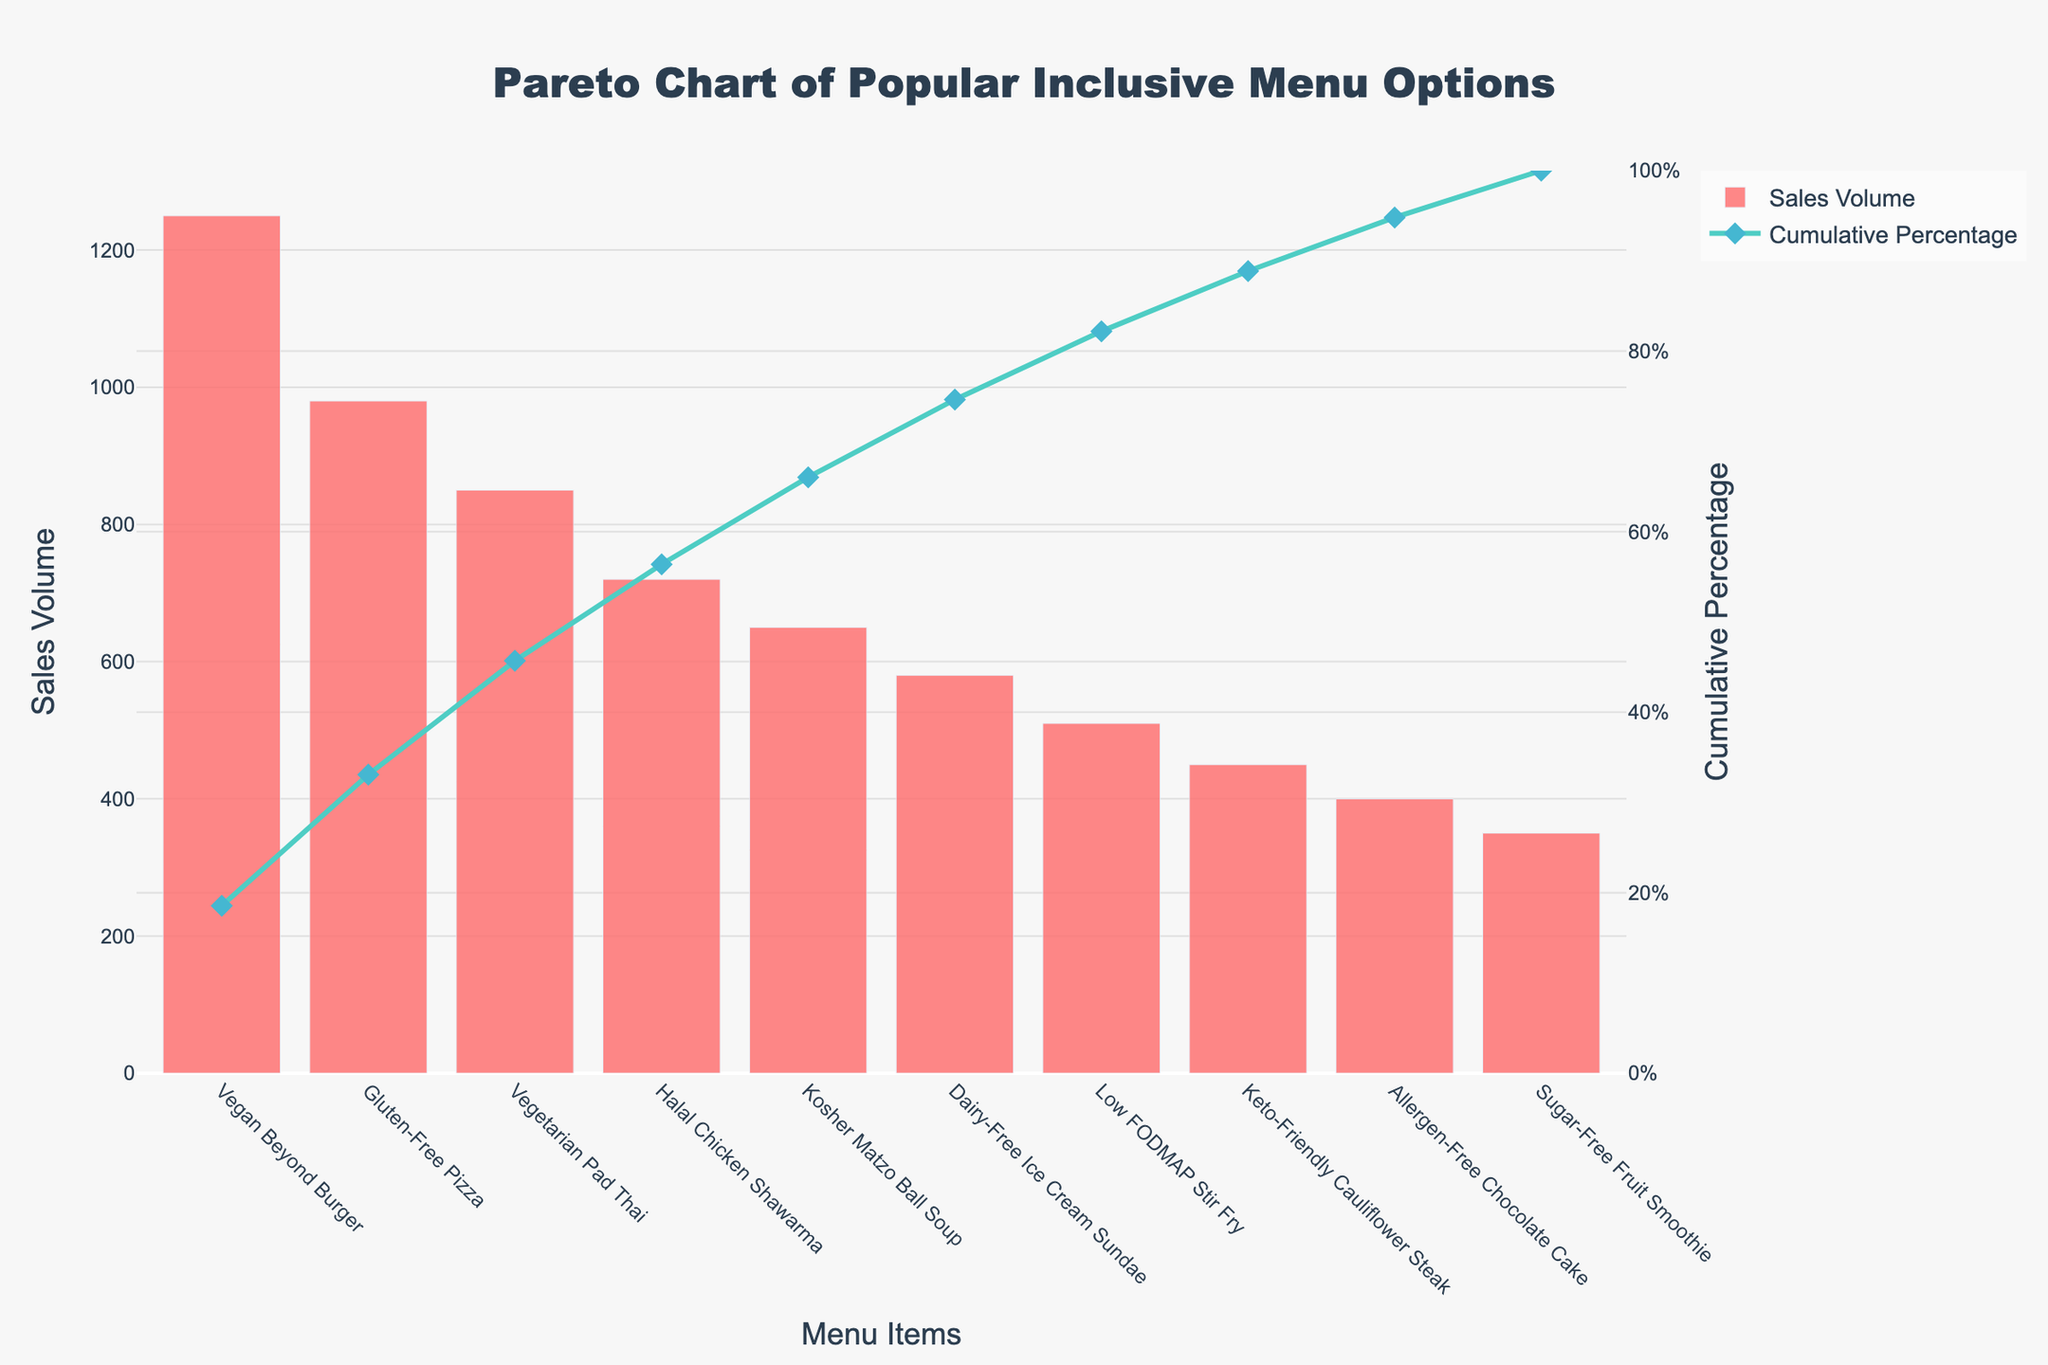What is the title of the chart? The title is displayed at the top of the chart and is "Pareto Chart of Popular Inclusive Menu Options".
Answer: Pareto Chart of Popular Inclusive Menu Options What are the top three menu items with the highest sales volume? By looking at the height of the bars, you can identify the top three menu items by their sales volume: "Vegan Beyond Burger", "Gluten-Free Pizza", and "Vegetarian Pad Thai".
Answer: Vegan Beyond Burger, Gluten-Free Pizza, Vegetarian Pad Thai Which menu item has the lowest sales volume? The shortest bar indicates the menu item with the lowest sales volume, which is "Sugar-Free Fruit Smoothie".
Answer: Sugar-Free Fruit Smoothie What is the color of the bars representing sales volume? The bars representing sales volume are in a specific color that is shown prominently in the chart.
Answer: Red What is the cumulative percentage for "Vegetarian Pad Thai"? The cumulative percentage line shows the cumulative percentage up to "Vegetarian Pad Thai", which is approximately 65%.
Answer: 65% How many menu items are represented in the chart? Counting the number of bars or x-axis labels will give the total number of menu items represented.
Answer: 10 (Compositional) What is the total sales volume for "Vegan Beyond Burger" and "Gluten-Free Pizza"? Summing the sales volumes of "Vegan Beyond Burger" (1250) and "Gluten-Free Pizza" (980) gives a total of 2230.
Answer: 2230 (Comparison) Which has a higher sales volume: "Halal Chicken Shawarma" or "Kosher Matzo Ball Soup"? By comparing the heights of their bars, "Halal Chicken Shawarma" has higher sales volume (720) than "Kosher Matzo Ball Soup" (650).
Answer: Halal Chicken Shawarma (Comparison) How does the cumulative percentage change from "Halal Chicken Shawarma" to "Kosher Matzo Ball Soup"? The cumulative percentage line shows an increase from 55% for "Halal Chicken Shawarma" to approximately 65% for "Kosher Matzo Ball Soup".
Answer: 10% (Chart-Type Specific) At which menu item does the cumulative percentage reach 100%? The cumulative percentage line reaches 100% at the last menu item, which in this case is "Sugar-Free Fruit Smoothie".
Answer: Sugar-Free Fruit Smoothie 